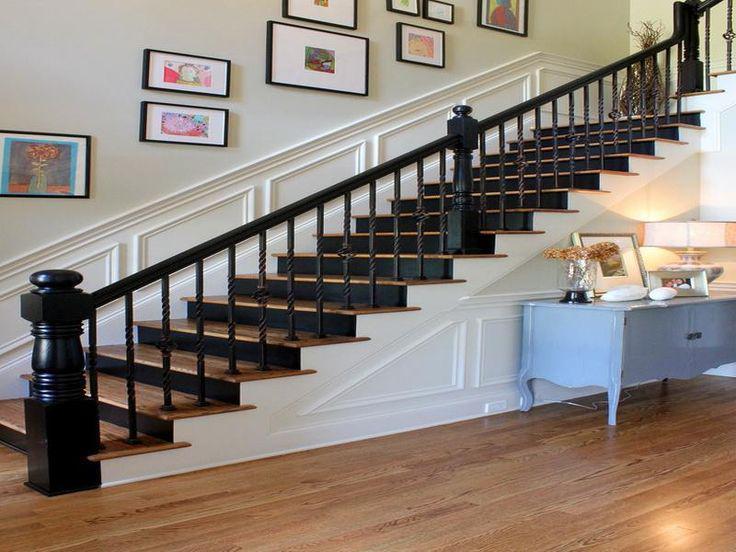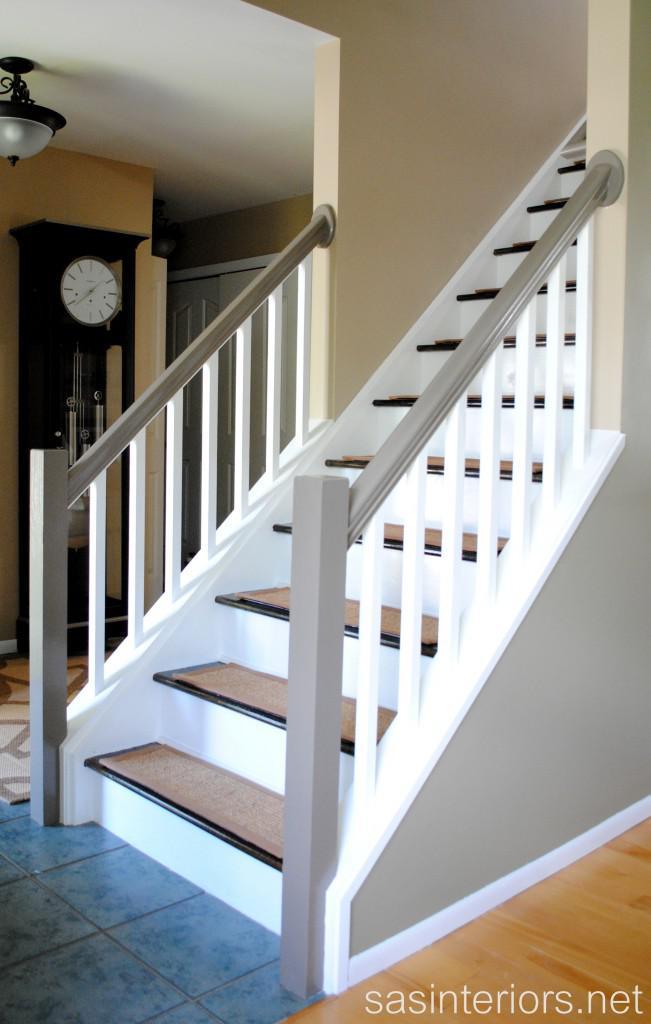The first image is the image on the left, the second image is the image on the right. Considering the images on both sides, is "In at least one image there are right facing stairs with black arm rails and white painted rods keeping it up." valid? Answer yes or no. No. The first image is the image on the left, the second image is the image on the right. For the images displayed, is the sentence "Each image shows a staircase that ascends to the right and has a wooden banister with only vertical bars and a closed-in bottom." factually correct? Answer yes or no. Yes. 